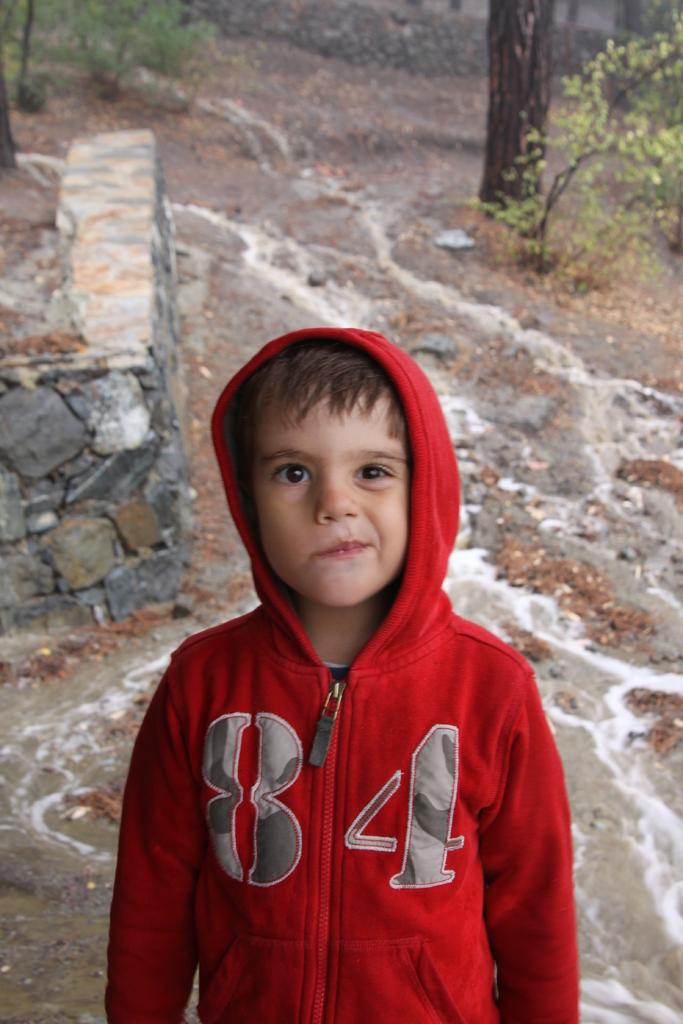<image>
Render a clear and concise summary of the photo. A young boy is shown outside wearing a red sweatshirt with the number 84 on it. 